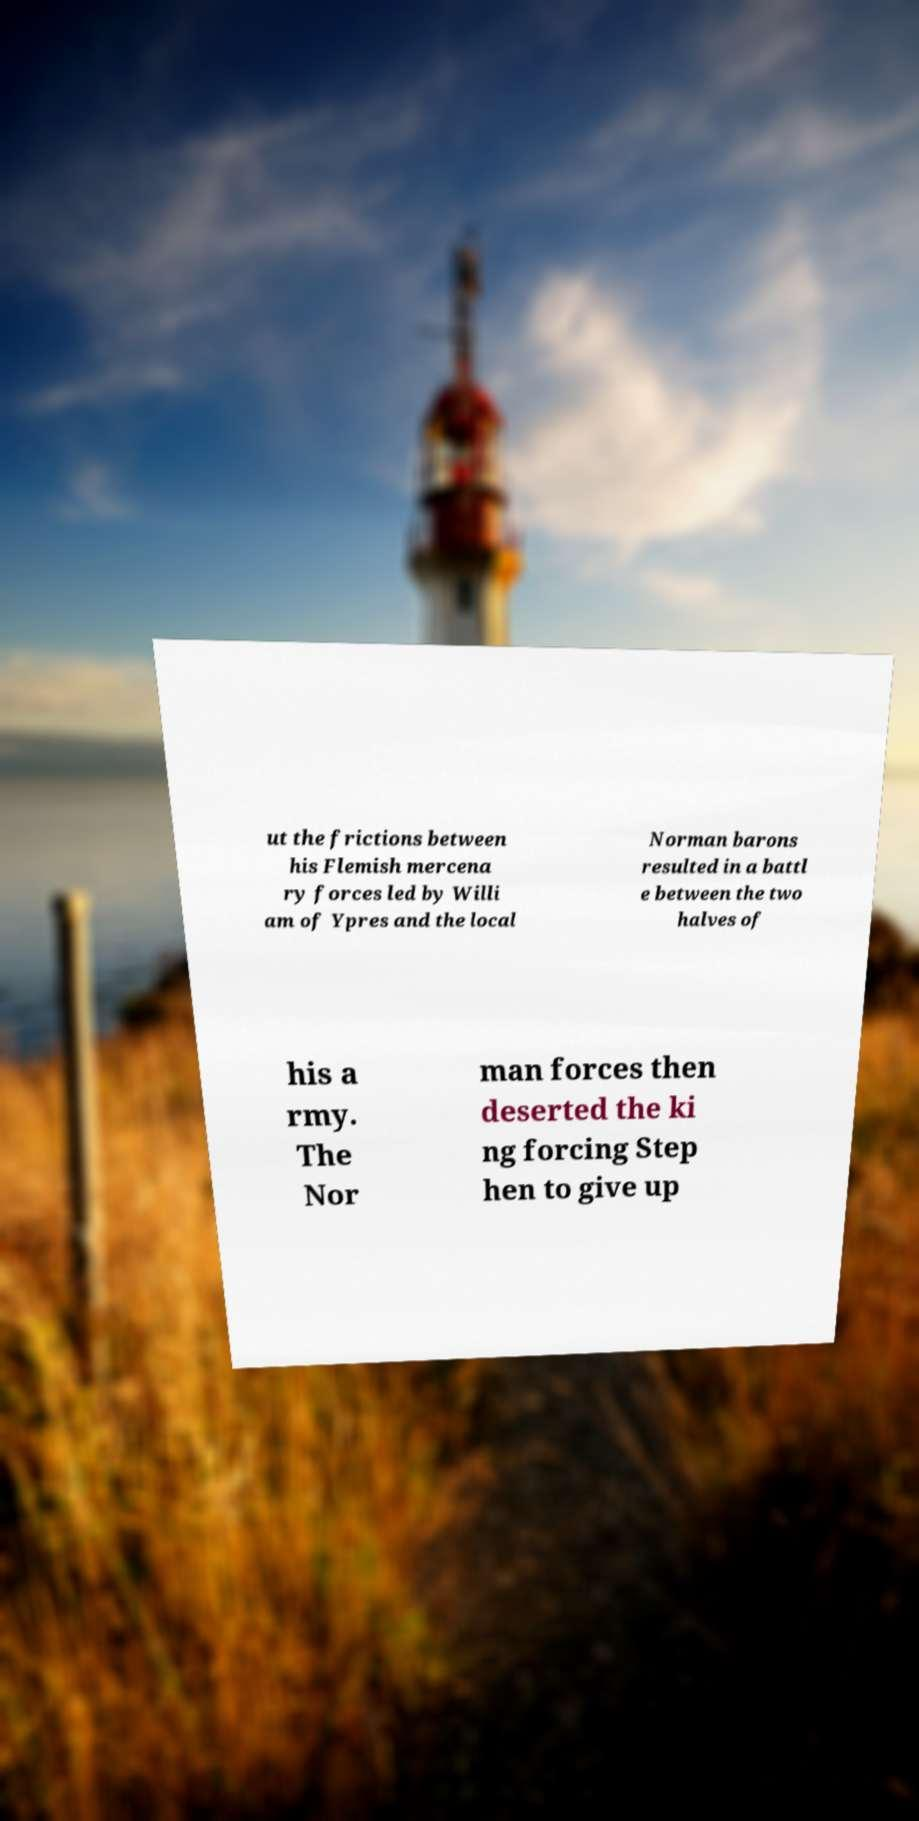What messages or text are displayed in this image? I need them in a readable, typed format. ut the frictions between his Flemish mercena ry forces led by Willi am of Ypres and the local Norman barons resulted in a battl e between the two halves of his a rmy. The Nor man forces then deserted the ki ng forcing Step hen to give up 